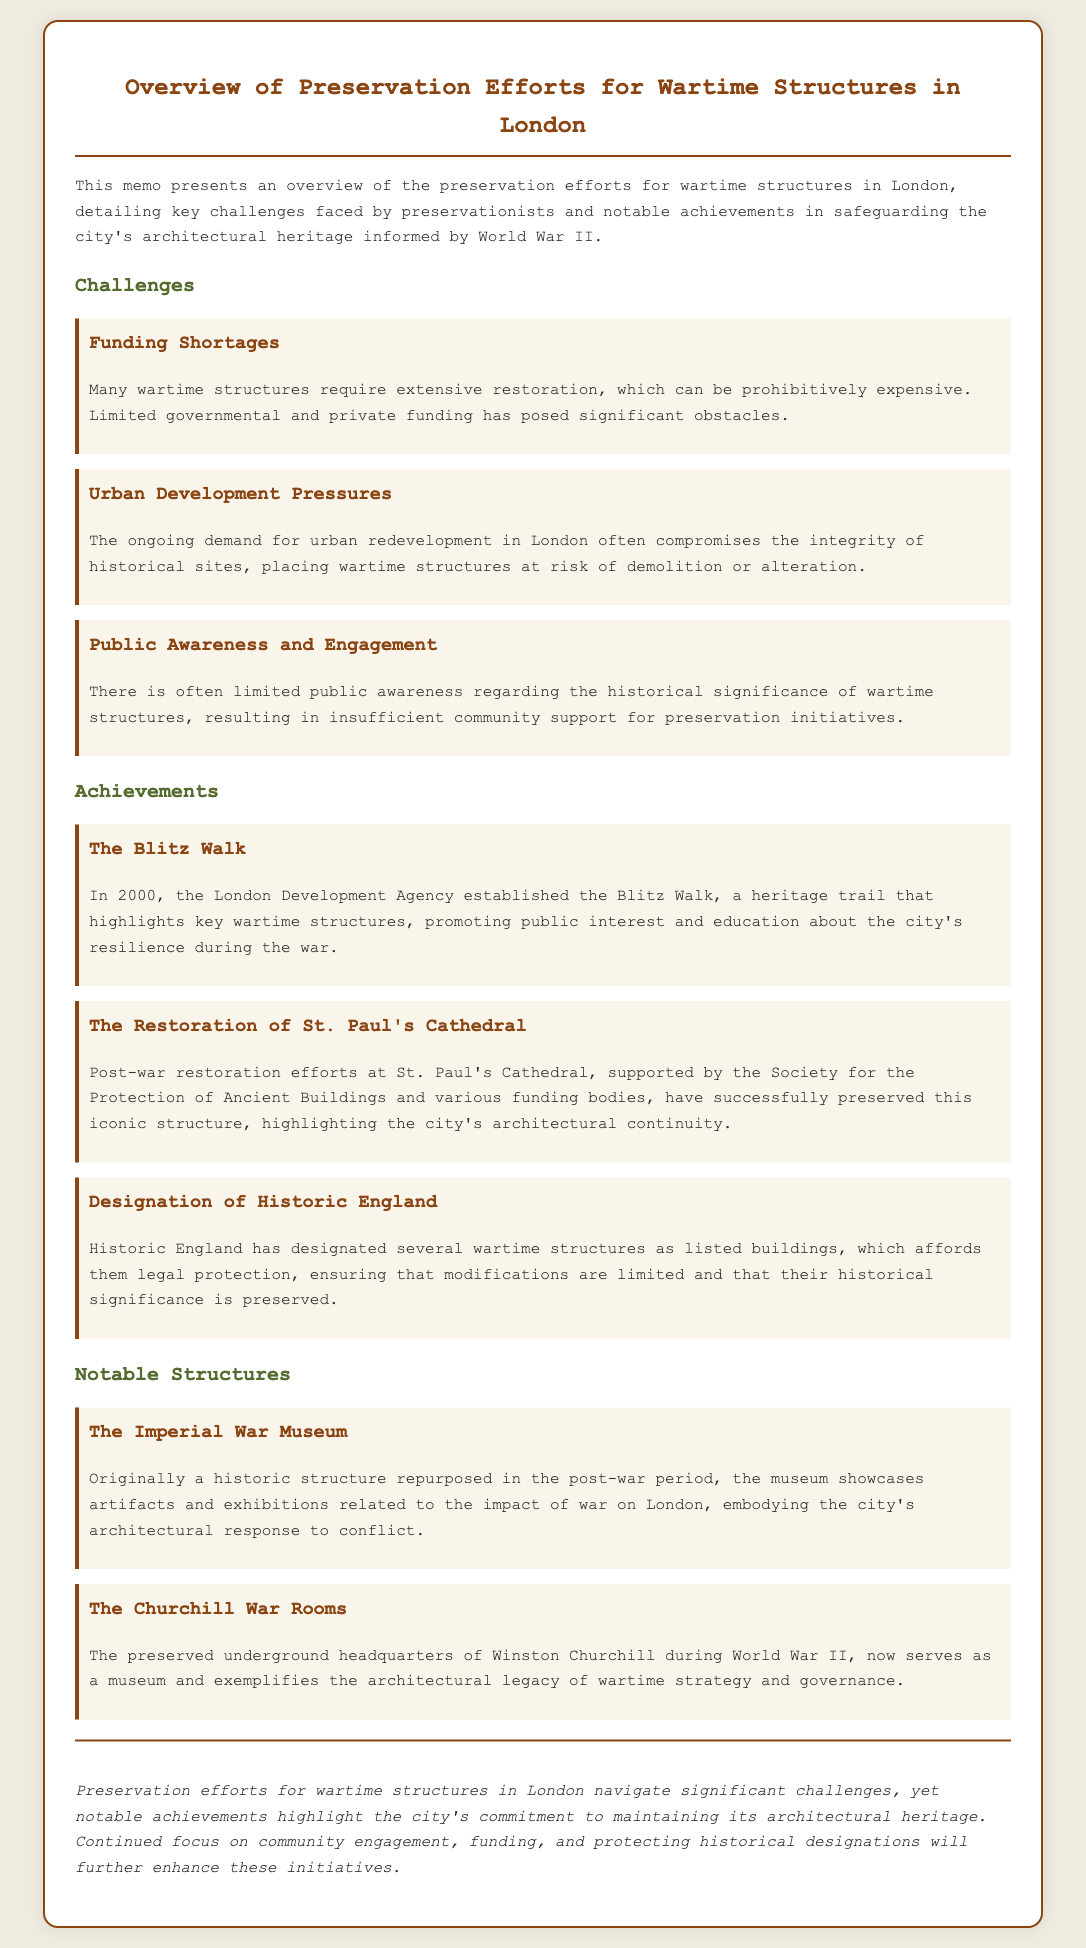What is the title of the memo? The title is explicitly provided in the document at the beginning of the content.
Answer: Overview of Preservation Efforts for Wartime Structures in London What year was The Blitz Walk established? The document states that The Blitz Walk was established in the year 2000.
Answer: 2000 Which structure is recognized for its post-war restoration efforts? The document highlights St. Paul's Cathedral specifically for its successful restoration.
Answer: St. Paul's Cathedral What organization designated several wartime structures as listed buildings? The document mentions Historic England as the organization responsible for these designations.
Answer: Historic England What challenge is associated with funding in preservation efforts? The document specifies "Funding Shortages" as a significant challenge faced by preservationists.
Answer: Funding Shortages How does the document describe public engagement with wartime structures? It denotes that there is often "limited public awareness" regarding these structures’ significance.
Answer: Limited public awareness What notable function does The Churchill War Rooms serve today? The document states that they now serve as a museum.
Answer: Museum What is the key purpose of the memo’s conclusion? The conclusion summarizes the challenges and achievements in preservation efforts along with future recommendations.
Answer: Summarizes challenges and achievements 